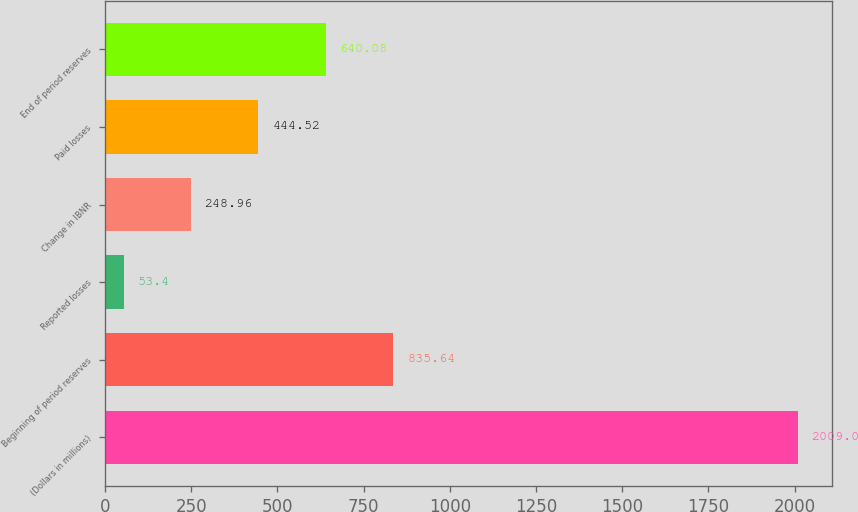<chart> <loc_0><loc_0><loc_500><loc_500><bar_chart><fcel>(Dollars in millions)<fcel>Beginning of period reserves<fcel>Reported losses<fcel>Change in IBNR<fcel>Paid losses<fcel>End of period reserves<nl><fcel>2009<fcel>835.64<fcel>53.4<fcel>248.96<fcel>444.52<fcel>640.08<nl></chart> 